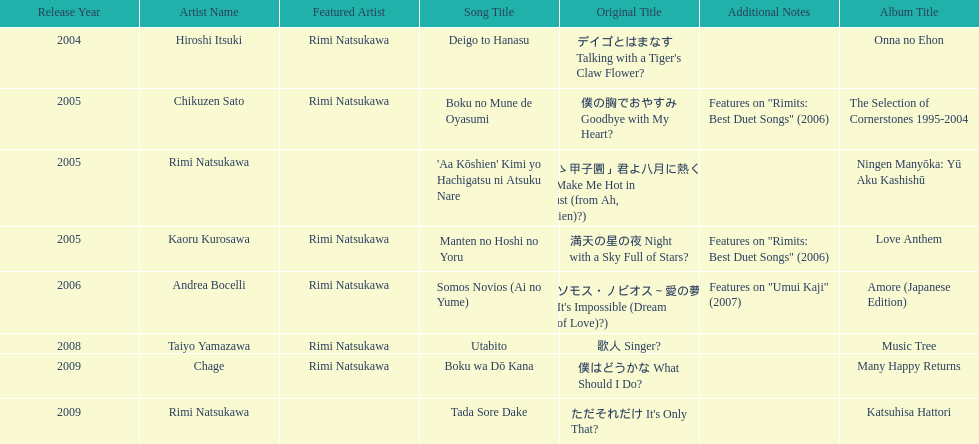What is the last title released? 2009. 